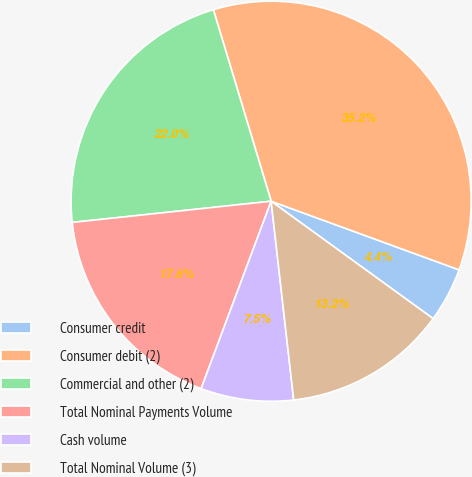Convert chart to OTSL. <chart><loc_0><loc_0><loc_500><loc_500><pie_chart><fcel>Consumer credit<fcel>Consumer debit (2)<fcel>Commercial and other (2)<fcel>Total Nominal Payments Volume<fcel>Cash volume<fcel>Total Nominal Volume (3)<nl><fcel>4.41%<fcel>35.24%<fcel>22.03%<fcel>17.62%<fcel>7.49%<fcel>13.22%<nl></chart> 